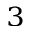Convert formula to latex. <formula><loc_0><loc_0><loc_500><loc_500>_ { 3 }</formula> 